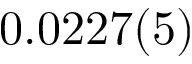Convert formula to latex. <formula><loc_0><loc_0><loc_500><loc_500>0 . 0 2 2 7 ( 5 )</formula> 